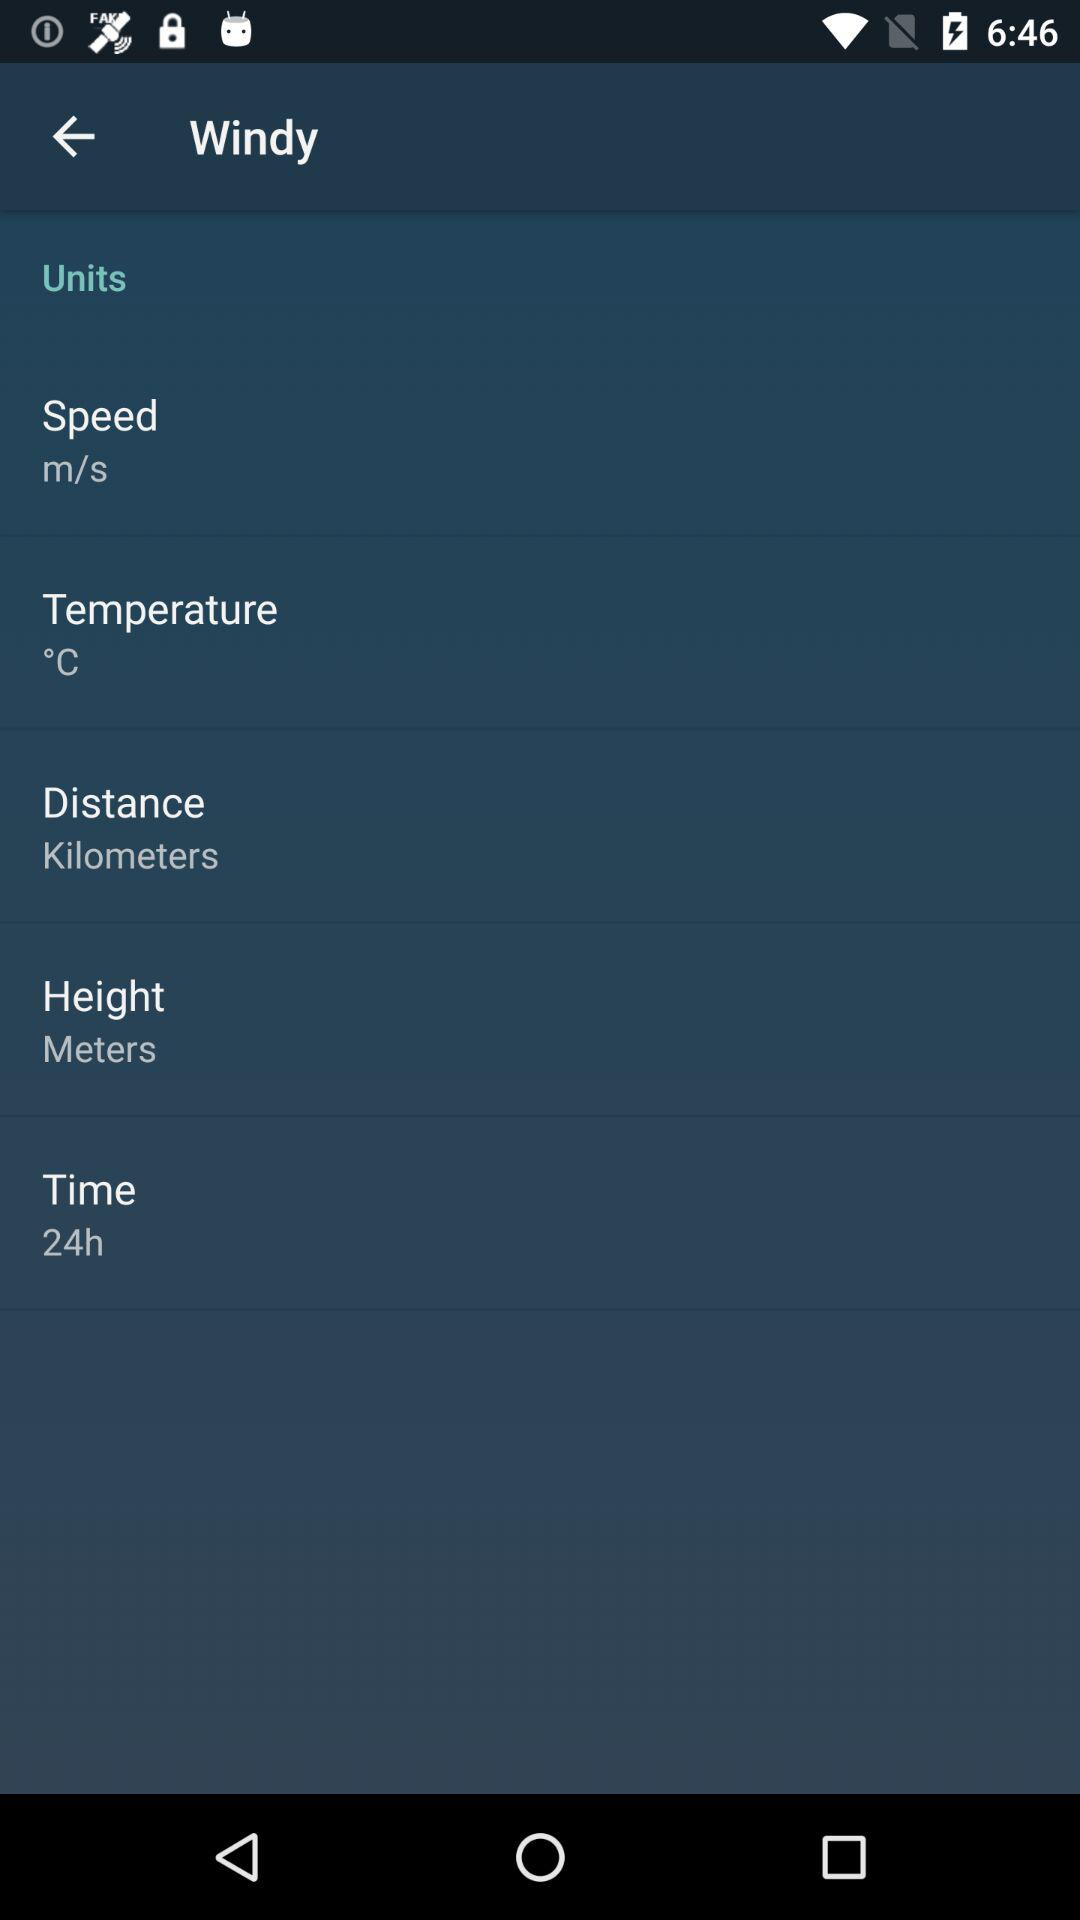What unit is selected for distance? The selected unit for distance is kilometers. 